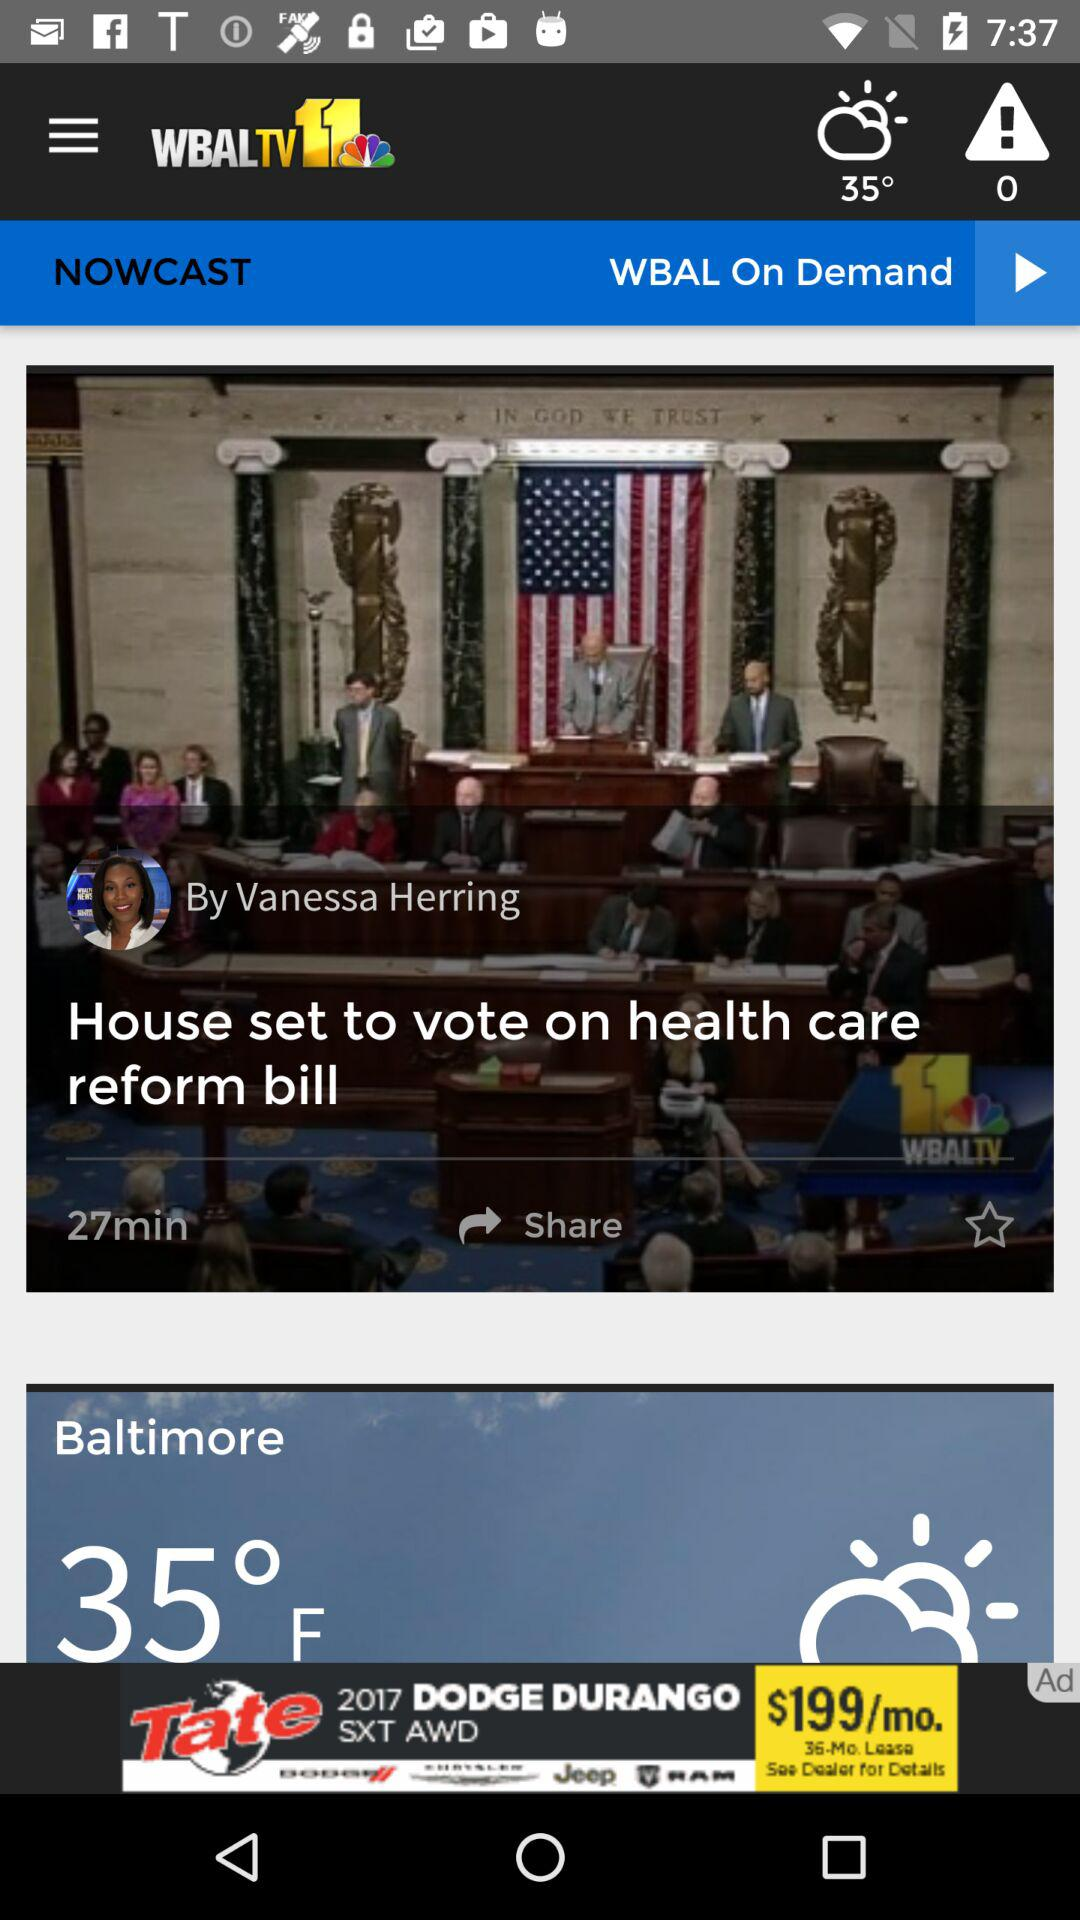How many minutes ago was the post "House set to vote on health care reform bill" posted? The post "House set to vote on health care reform bill" was posted 27 minutes ago. 